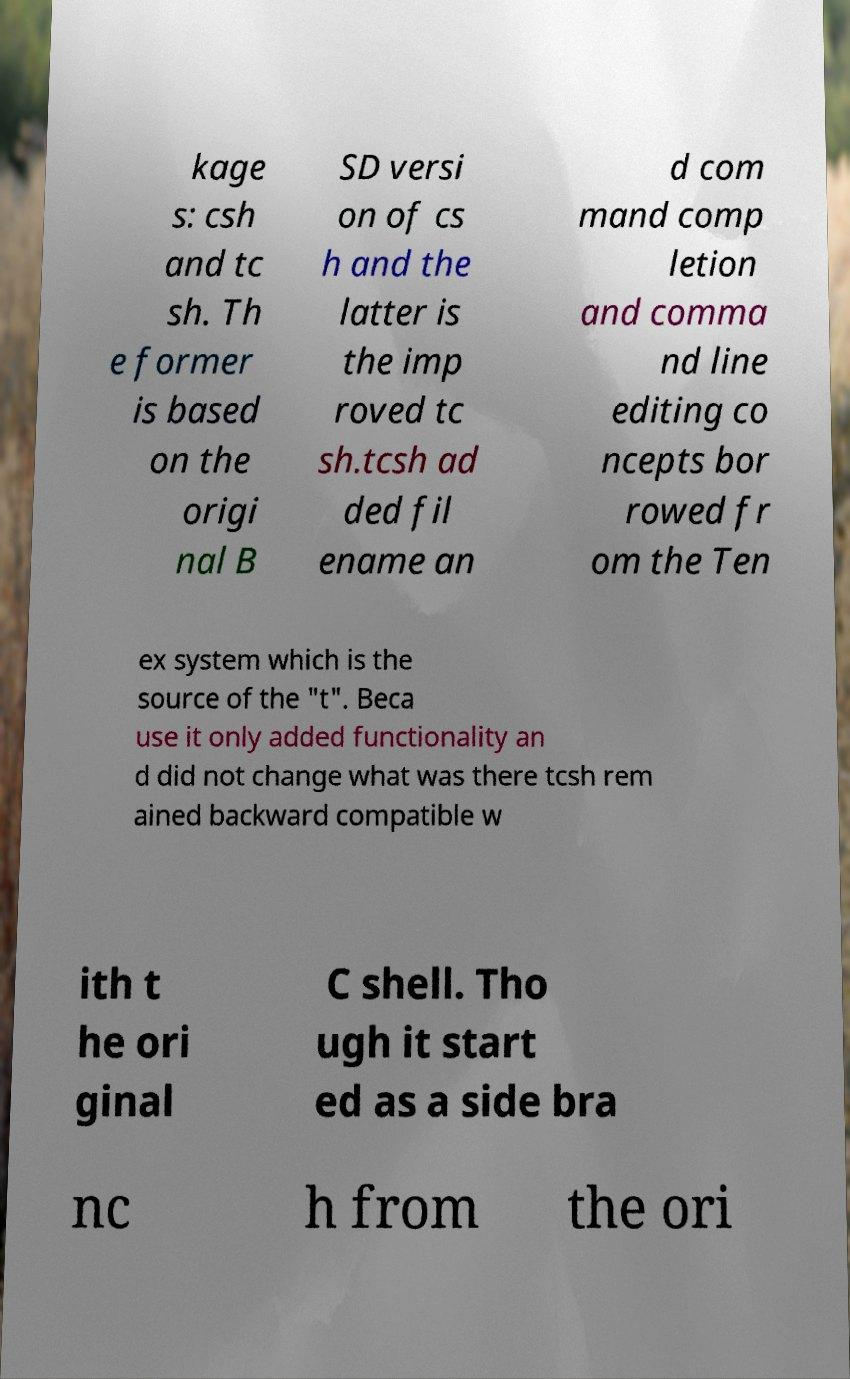For documentation purposes, I need the text within this image transcribed. Could you provide that? kage s: csh and tc sh. Th e former is based on the origi nal B SD versi on of cs h and the latter is the imp roved tc sh.tcsh ad ded fil ename an d com mand comp letion and comma nd line editing co ncepts bor rowed fr om the Ten ex system which is the source of the "t". Beca use it only added functionality an d did not change what was there tcsh rem ained backward compatible w ith t he ori ginal C shell. Tho ugh it start ed as a side bra nc h from the ori 